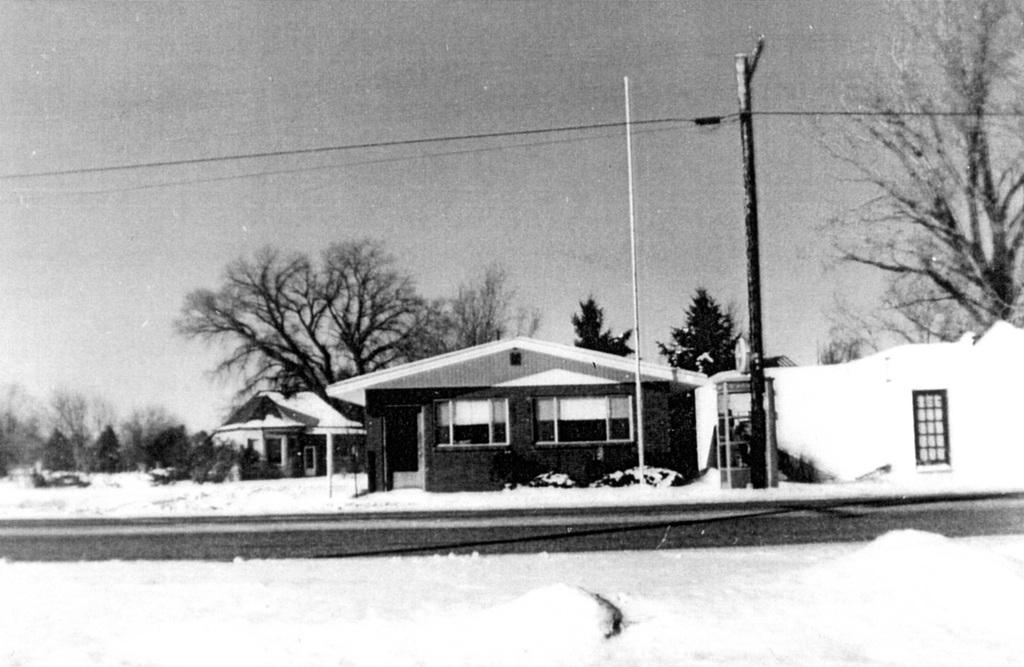What is the color scheme of the image? The image is black and white. What type of structures can be seen in the image? There are houses in the image. What type of vegetation is present around the houses? There are trees around the houses. What is the terrain like in the image? The land is covered with ice. What type of mask is being worn by the trees in the image? There are no masks present in the image, and the trees are not wearing any. 